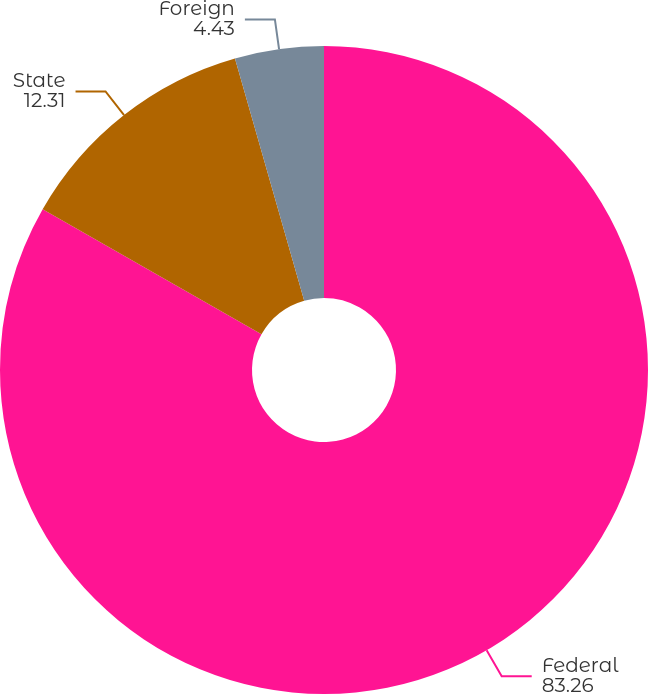Convert chart. <chart><loc_0><loc_0><loc_500><loc_500><pie_chart><fcel>Federal<fcel>State<fcel>Foreign<nl><fcel>83.26%<fcel>12.31%<fcel>4.43%<nl></chart> 